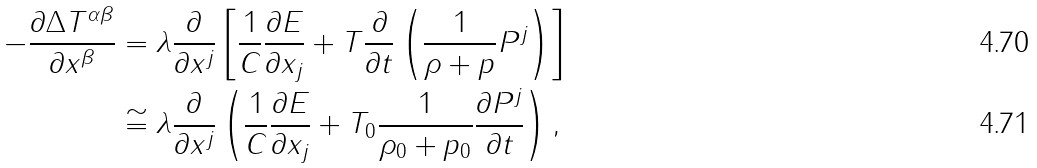<formula> <loc_0><loc_0><loc_500><loc_500>- \frac { \partial \Delta T ^ { \alpha \beta } } { \partial x ^ { \beta } } & = \lambda \frac { \partial } { \partial x ^ { j } } \left [ \frac { 1 } { C } \frac { \partial E } { \partial x _ { j } } + T \frac { \partial } { \partial t } \left ( \frac { 1 } { \rho + p } P ^ { j } \right ) \right ] \\ & \cong \lambda \frac { \partial } { \partial x ^ { j } } \left ( \frac { 1 } { C } \frac { \partial E } { \partial x _ { j } } + T _ { 0 } \frac { 1 } { \rho _ { 0 } + p _ { 0 } } \frac { \partial P ^ { j } } { \partial t } \right ) ,</formula> 